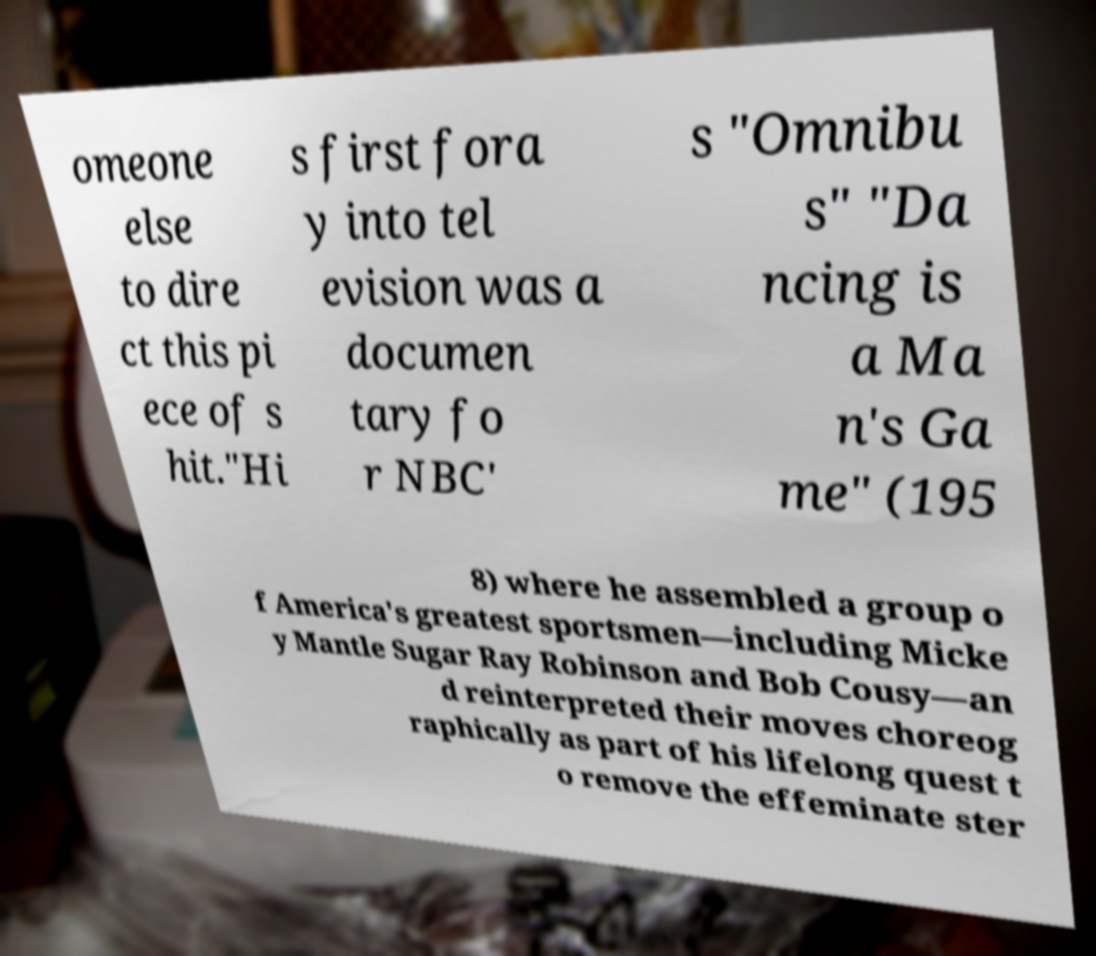I need the written content from this picture converted into text. Can you do that? omeone else to dire ct this pi ece of s hit."Hi s first fora y into tel evision was a documen tary fo r NBC' s "Omnibu s" "Da ncing is a Ma n's Ga me" (195 8) where he assembled a group o f America's greatest sportsmen—including Micke y Mantle Sugar Ray Robinson and Bob Cousy—an d reinterpreted their moves choreog raphically as part of his lifelong quest t o remove the effeminate ster 